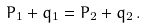<formula> <loc_0><loc_0><loc_500><loc_500>P _ { 1 } + q _ { 1 } = P _ { 2 } + q _ { 2 } \, .</formula> 